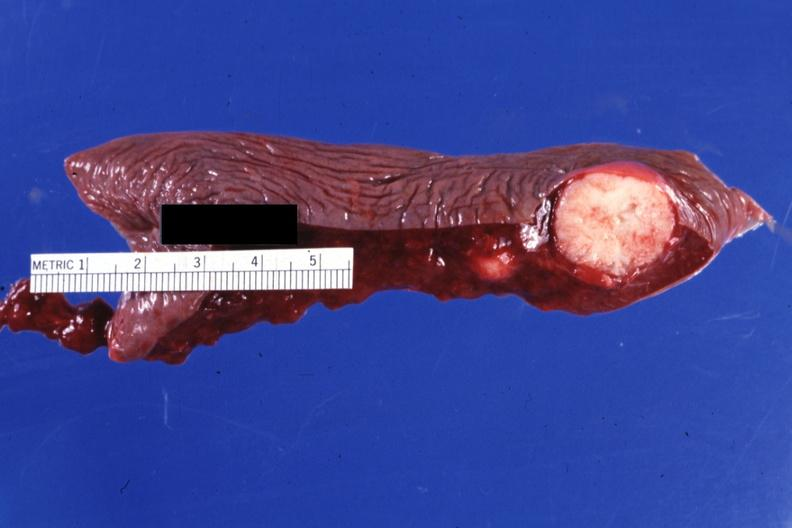what does this image show?
Answer the question using a single word or phrase. Cut surface typical 